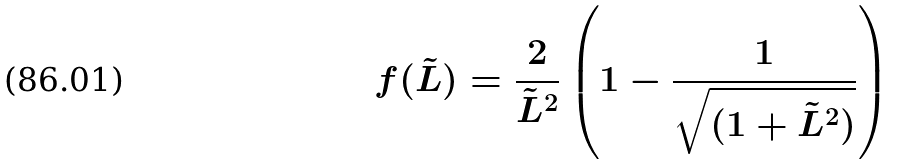<formula> <loc_0><loc_0><loc_500><loc_500>f ( \tilde { L } ) = \frac { 2 } { \tilde { L } ^ { 2 } } \left ( 1 - \frac { 1 } { \sqrt { ( 1 + \tilde { L } ^ { 2 } ) } } \right )</formula> 